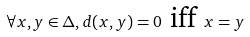Convert formula to latex. <formula><loc_0><loc_0><loc_500><loc_500>\forall x , y \in \Delta , d ( x , y ) = 0 \text { iff } x = y</formula> 